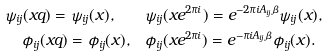Convert formula to latex. <formula><loc_0><loc_0><loc_500><loc_500>\psi _ { i j } ( x q ) = \psi _ { i j } ( x ) , \quad & \psi _ { i j } ( x e ^ { 2 \pi i } ) = e ^ { - 2 \pi i A _ { i j } \beta } \psi _ { i j } ( x ) , \\ \phi _ { i j } ( x q ) = \phi _ { i j } ( x ) , \quad & \phi _ { i j } ( x e ^ { 2 \pi i } ) = e ^ { - \pi i A _ { i j } \beta } \phi _ { i j } ( x ) .</formula> 